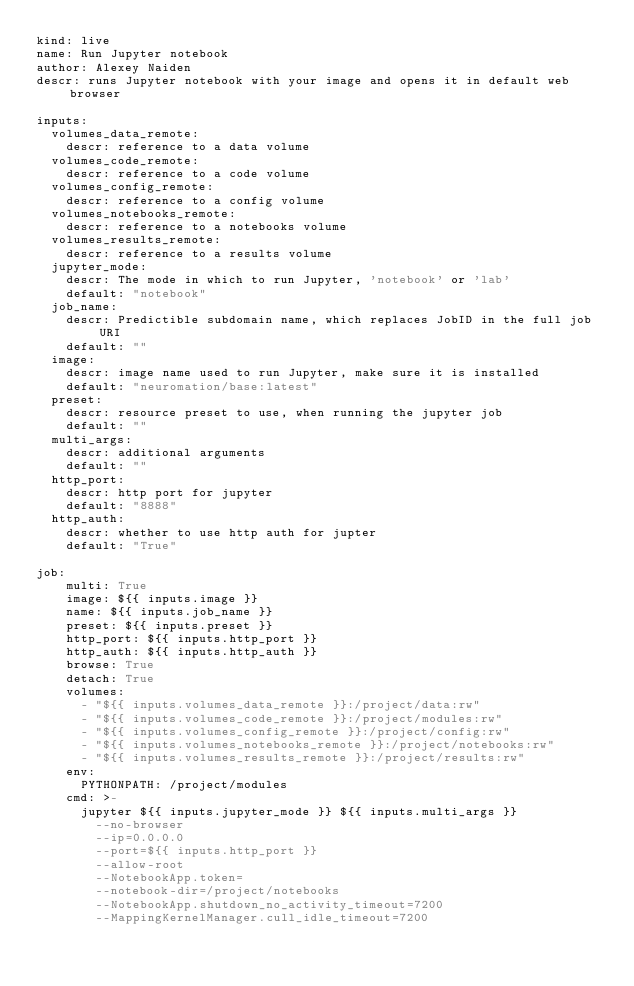<code> <loc_0><loc_0><loc_500><loc_500><_YAML_>kind: live
name: Run Jupyter notebook
author: Alexey Naiden
descr: runs Jupyter notebook with your image and opens it in default web browser

inputs:
  volumes_data_remote:
    descr: reference to a data volume
  volumes_code_remote:
    descr: reference to a code volume
  volumes_config_remote:
    descr: reference to a config volume
  volumes_notebooks_remote:
    descr: reference to a notebooks volume
  volumes_results_remote:
    descr: reference to a results volume
  jupyter_mode:
    descr: The mode in which to run Jupyter, 'notebook' or 'lab'
    default: "notebook"
  job_name:
    descr: Predictible subdomain name, which replaces JobID in the full job URI
    default: ""
  image:
    descr: image name used to run Jupyter, make sure it is installed
    default: "neuromation/base:latest"
  preset:
    descr: resource preset to use, when running the jupyter job
    default: ""
  multi_args:
    descr: additional arguments
    default: ""
  http_port:
    descr: http port for jupyter
    default: "8888"
  http_auth:
    descr: whether to use http auth for jupter
    default: "True"

job:
    multi: True
    image: ${{ inputs.image }}
    name: ${{ inputs.job_name }}
    preset: ${{ inputs.preset }}
    http_port: ${{ inputs.http_port }}
    http_auth: ${{ inputs.http_auth }}
    browse: True
    detach: True
    volumes:
      - "${{ inputs.volumes_data_remote }}:/project/data:rw"
      - "${{ inputs.volumes_code_remote }}:/project/modules:rw"
      - "${{ inputs.volumes_config_remote }}:/project/config:rw"
      - "${{ inputs.volumes_notebooks_remote }}:/project/notebooks:rw"
      - "${{ inputs.volumes_results_remote }}:/project/results:rw"
    env:
      PYTHONPATH: /project/modules
    cmd: >-
      jupyter ${{ inputs.jupyter_mode }} ${{ inputs.multi_args }}
        --no-browser
        --ip=0.0.0.0
        --port=${{ inputs.http_port }}
        --allow-root
        --NotebookApp.token=
        --notebook-dir=/project/notebooks
        --NotebookApp.shutdown_no_activity_timeout=7200
        --MappingKernelManager.cull_idle_timeout=7200
</code> 